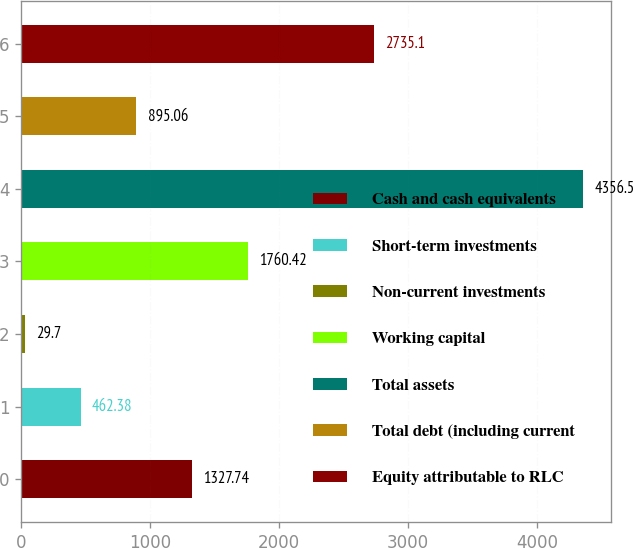Convert chart to OTSL. <chart><loc_0><loc_0><loc_500><loc_500><bar_chart><fcel>Cash and cash equivalents<fcel>Short-term investments<fcel>Non-current investments<fcel>Working capital<fcel>Total assets<fcel>Total debt (including current<fcel>Equity attributable to RLC<nl><fcel>1327.74<fcel>462.38<fcel>29.7<fcel>1760.42<fcel>4356.5<fcel>895.06<fcel>2735.1<nl></chart> 